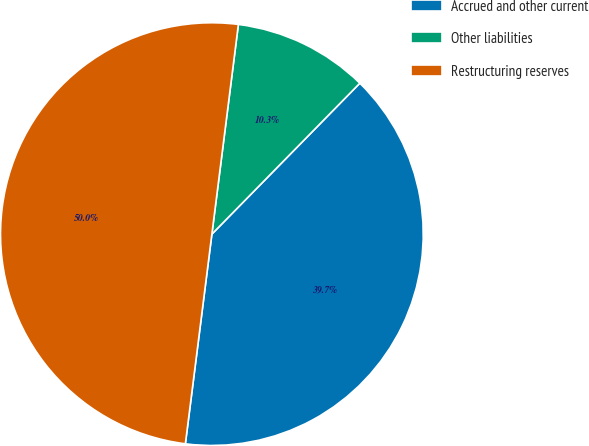Convert chart. <chart><loc_0><loc_0><loc_500><loc_500><pie_chart><fcel>Accrued and other current<fcel>Other liabilities<fcel>Restructuring reserves<nl><fcel>39.66%<fcel>10.34%<fcel>50.0%<nl></chart> 